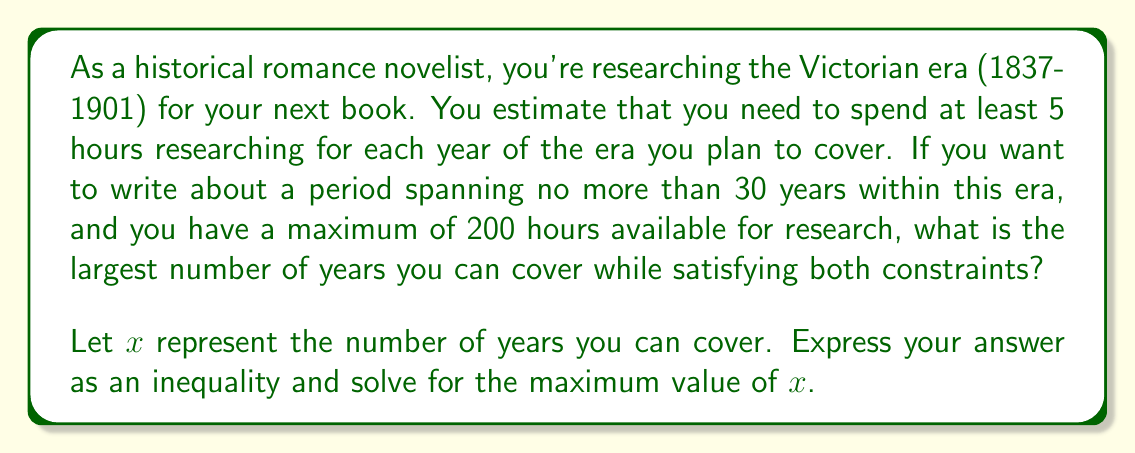Can you answer this question? Let's approach this step-by-step:

1) First, let's establish our constraints:
   - We need at least 5 hours of research per year: $5x \leq 200$
   - We can't cover more than 30 years: $x \leq 30$
   - We can't exceed 200 hours of research: $5x \leq 200$

2) We can combine these into a system of inequalities:

   $$\begin{cases}
   5x \leq 200 \\
   x \leq 30
   \end{cases}$$

3) To find the maximum value of $x$, we need to solve both inequalities:

   From $5x \leq 200$:
   $$x \leq \frac{200}{5} = 40$$

   From $x \leq 30$:
   $$x \leq 30$$

4) The solution to our system of inequalities is the intersection of these two solutions. Since 30 is less than 40, the more restrictive inequality is $x \leq 30$.

5) Therefore, the maximum value of $x$ that satisfies both constraints is 30.

This means you can cover at most 30 years while staying within your 200-hour research budget and the 30-year maximum period.
Answer: The largest number of years that can be covered is 30, satisfying the inequality $x \leq 30$. 